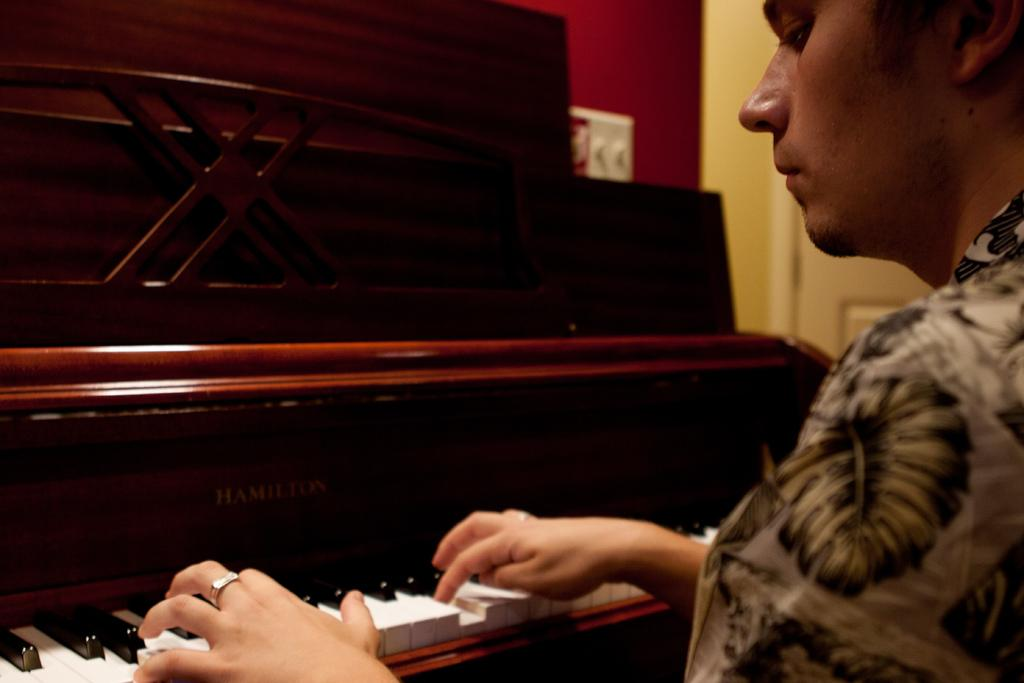What is the man in the image doing? The man is playing the violin. How is the man playing the violin? The man is using his hands to play the violin. What is the man wearing in the image? The man is wearing a shirt. What is the color pattern of the violin keys? The keys of the violin are in black and white color. How many cows are present in the image? There are no cows present in the image; it features a man playing the violin. What type of secretary is assisting the man in the image? There is no secretary present in the image; it only features a man playing the violin. 